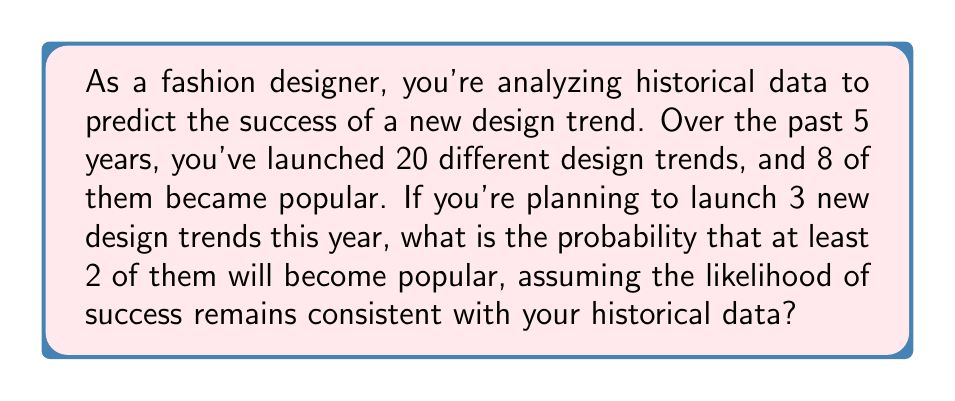Give your solution to this math problem. To solve this problem, we'll use the binomial probability distribution. Let's break it down step-by-step:

1. Calculate the probability of a single design trend becoming popular:
   $p = \frac{\text{number of successful trends}}{\text{total number of trends}} = \frac{8}{20} = 0.4$

2. The probability of a trend not becoming popular is:
   $q = 1 - p = 1 - 0.4 = 0.6$

3. We want the probability of at least 2 out of 3 trends becoming popular. This can happen in two ways:
   a) Exactly 2 out of 3 become popular
   b) All 3 become popular

4. Let's calculate the probability of each scenario:

   a) Probability of exactly 2 out of 3 becoming popular:
      $$P(X=2) = \binom{3}{2} p^2 q^1 = 3 \cdot (0.4)^2 \cdot (0.6)^1 = 3 \cdot 0.16 \cdot 0.6 = 0.288$$

   b) Probability of all 3 becoming popular:
      $$P(X=3) = \binom{3}{3} p^3 = (0.4)^3 = 0.064$$

5. The probability of at least 2 out of 3 becoming popular is the sum of these probabilities:
   $$P(X \geq 2) = P(X=2) + P(X=3) = 0.288 + 0.064 = 0.352$$

Therefore, the probability that at least 2 out of 3 new design trends will become popular is 0.352 or 35.2%.
Answer: 0.352 or 35.2% 